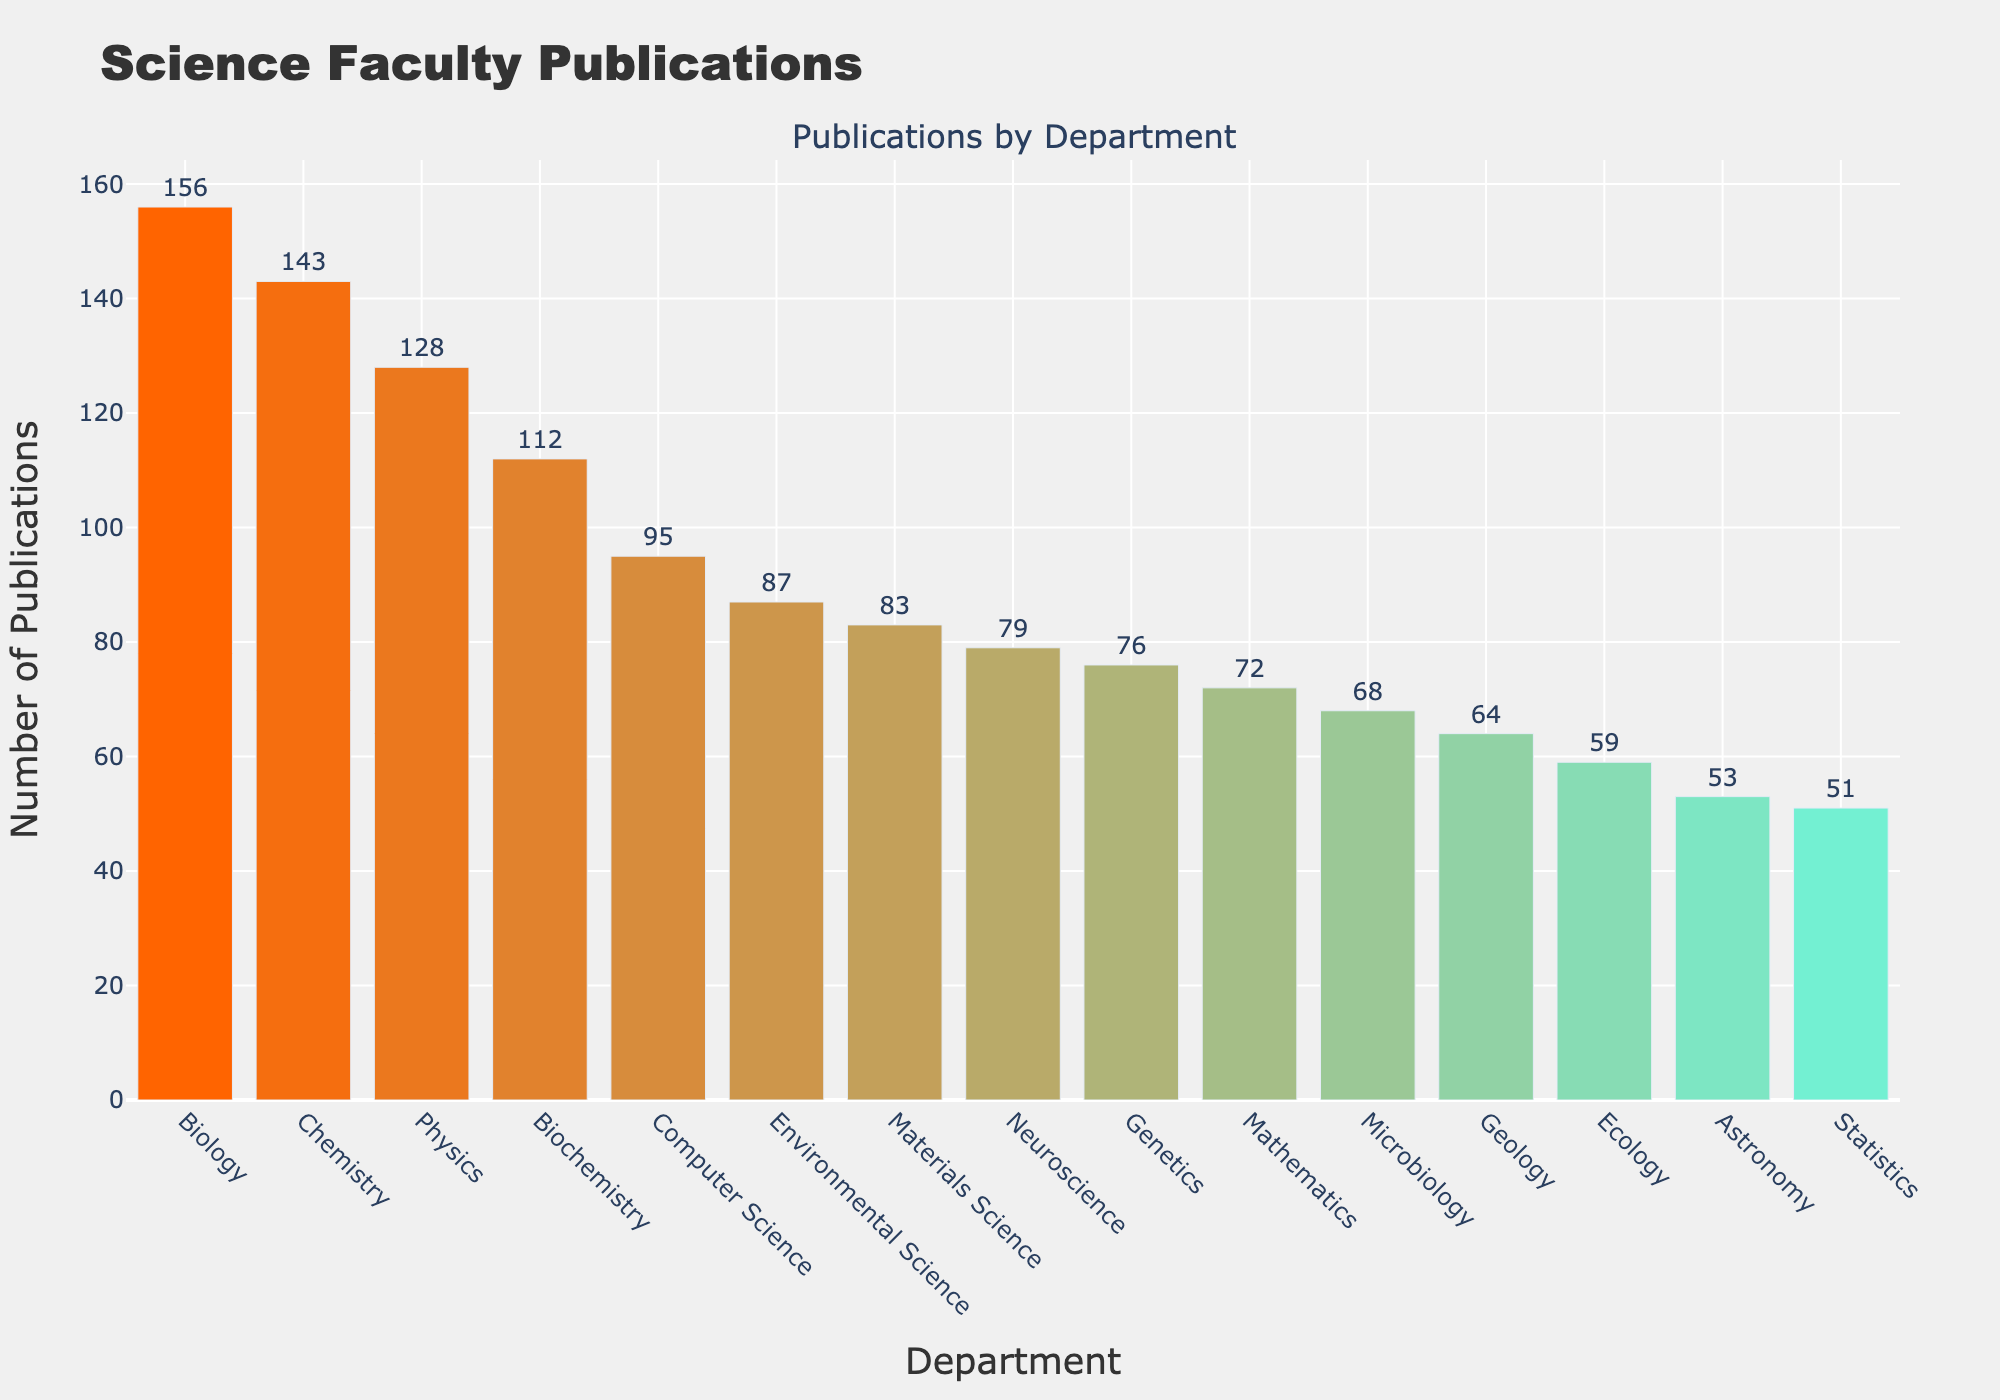What's the department with the most publications? The figure shows the number of publications by each department. The department with the highest bar has the most publications. In this case, it's Biology with 156 publications.
Answer: Biology Which department has the fewest publications? By observing the bar lengths, the shortest bar represents the department with the fewest publications. Astronomy has the fewest with 53 publications.
Answer: Astronomy What is the difference in the number of publications between Biology and Chemistry? First, find the number of publications for Biology (156) and Chemistry (143). Subtract the two values: 156 - 143 = 13.
Answer: 13 What is the average number of publications across all departments? Sum all the publication numbers and divide by the number of departments: (156 + 143 + 128 + 87 + 72 + 95 + 64 + 53 + 79 + 112 + 68 + 51 + 76 + 59 + 83) / 15 = 1256 / 15 = approximately 83.7.
Answer: 83.7 How many more publications does Computer Science have compared to Mathematics? Locate the publications for Computer Science (95) and Mathematics (72), then subtract: 95 - 72 = 23.
Answer: 23 Which departments have more than 100 publications? Identify bars that extend beyond the 100 mark on the y-axis. Departments with more than 100 publications are Biology (156), Chemistry (143), Physics (128), and Biochemistry (112).
Answer: Biology, Chemistry, Physics, Biochemistry What is the sum of publications for the top 3 departments? The top 3 departments are Biology (156), Chemistry (143), and Physics (128). Add these numbers together: 156 + 143 + 128 = 427.
Answer: 427 Which department has the tallest bar in terms of height, and what does it represent? The tallest bar visually represents the department with the most publications. It is Biology, which represents 156 publications.
Answer: Biology, 156 What is the median number of publications? First, list the publications in ascending order: 51, 53, 59, 64, 68, 72, 76, 79, 83, 87, 95, 112, 128, 143, 156. The median value, which is the middle number in an ordered list, is the 8th value: 79.
Answer: 79 How many departments have fewer than 70 publications? Identify bars that are below the 70 mark on the y-axis. Departments with fewer than 70 publications are Geology (64), Astronomy (53), Microbiology (68), Statistics (51), and Ecology (59). 5 departments in total.
Answer: 5 